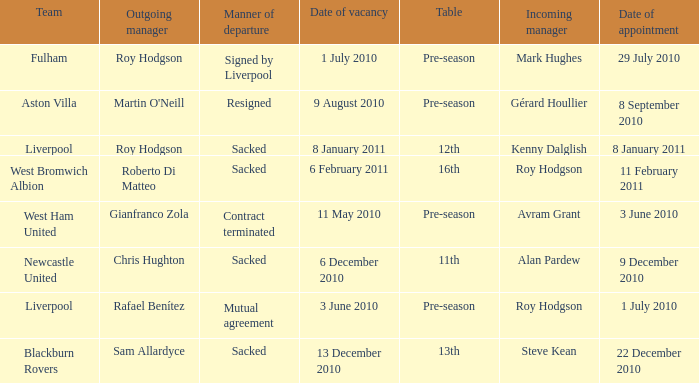What is the table for the team Blackburn Rovers? 13th. 